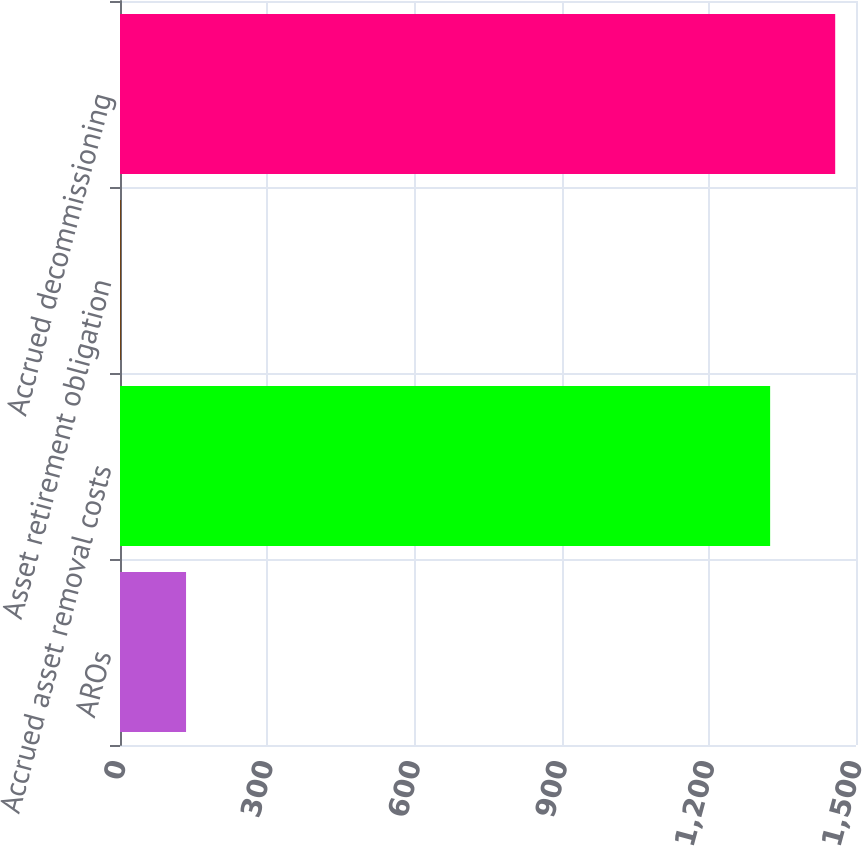Convert chart to OTSL. <chart><loc_0><loc_0><loc_500><loc_500><bar_chart><fcel>AROs<fcel>Accrued asset removal costs<fcel>Asset retirement obligation<fcel>Accrued decommissioning<nl><fcel>134.6<fcel>1325<fcel>2<fcel>1457.6<nl></chart> 